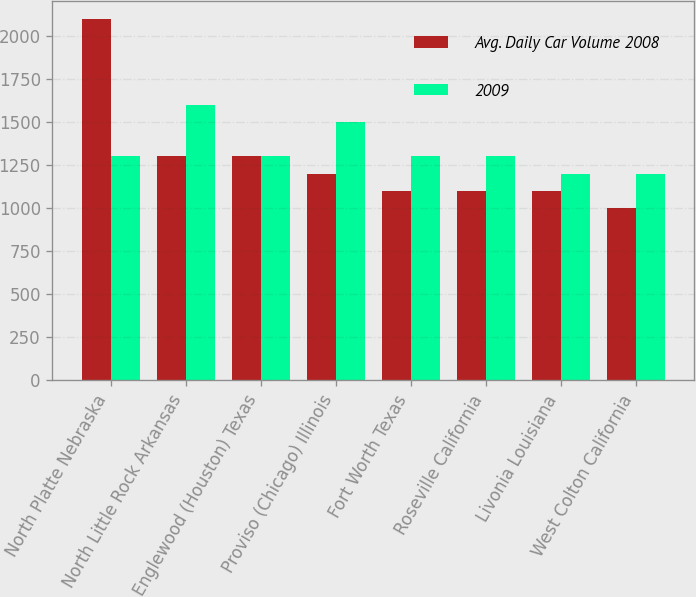Convert chart to OTSL. <chart><loc_0><loc_0><loc_500><loc_500><stacked_bar_chart><ecel><fcel>North Platte Nebraska<fcel>North Little Rock Arkansas<fcel>Englewood (Houston) Texas<fcel>Proviso (Chicago) Illinois<fcel>Fort Worth Texas<fcel>Roseville California<fcel>Livonia Louisiana<fcel>West Colton California<nl><fcel>Avg. Daily Car Volume 2008<fcel>2100<fcel>1300<fcel>1300<fcel>1200<fcel>1100<fcel>1100<fcel>1100<fcel>1000<nl><fcel>2009<fcel>1300<fcel>1600<fcel>1300<fcel>1500<fcel>1300<fcel>1300<fcel>1200<fcel>1200<nl></chart> 